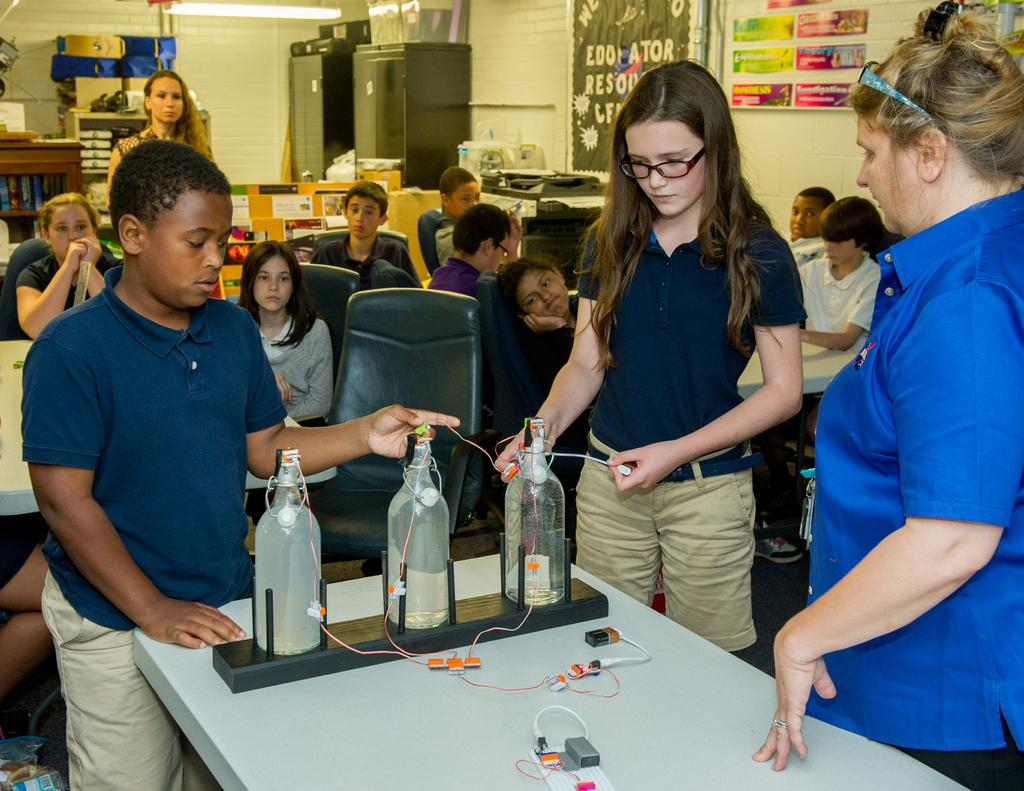What type of people are in the image? There are students in the image. What positions are the students in? Some students are sitting, and some students are standing. What are the students doing in the image? The students are showing an experiment. What type of degree is the doctor holding in the image? There is no doctor or degree present in the image; it features students showing an experiment. What type of writing instrument is the student using to take notes during the experiment? There is no indication in the image that the students are taking notes or using any writing instruments. 